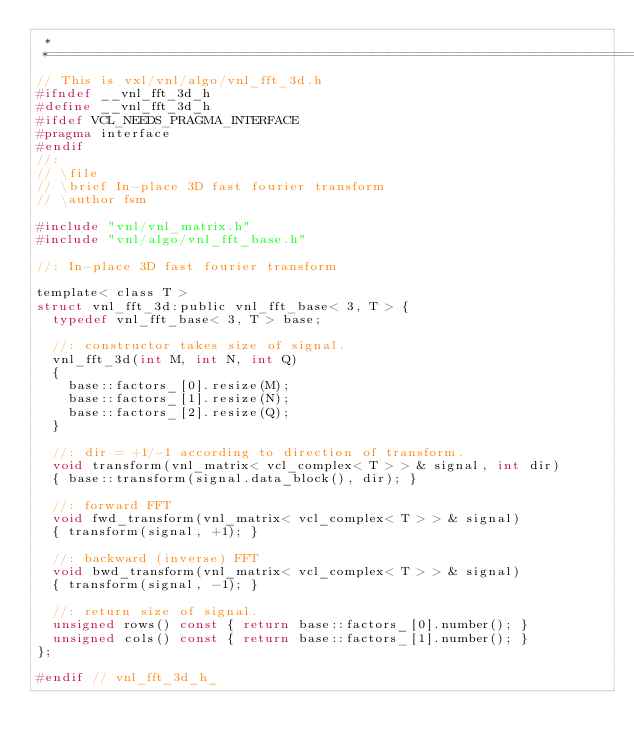Convert code to text. <code><loc_0><loc_0><loc_500><loc_500><_C_> *
 *=========================================================================*/
// This is vxl/vnl/algo/vnl_fft_3d.h
#ifndef __vnl_fft_3d_h
#define __vnl_fft_3d_h
#ifdef VCL_NEEDS_PRAGMA_INTERFACE
#pragma interface
#endif
//:
// \file
// \brief In-place 3D fast fourier transform
// \author fsm

#include "vnl/vnl_matrix.h"
#include "vnl/algo/vnl_fft_base.h"

//: In-place 3D fast fourier transform

template< class T >
struct vnl_fft_3d:public vnl_fft_base< 3, T > {
  typedef vnl_fft_base< 3, T > base;

  //: constructor takes size of signal.
  vnl_fft_3d(int M, int N, int Q)
  {
    base::factors_[0].resize(M);
    base::factors_[1].resize(N);
    base::factors_[2].resize(Q);
  }

  //: dir = +1/-1 according to direction of transform.
  void transform(vnl_matrix< vcl_complex< T > > & signal, int dir)
  { base::transform(signal.data_block(), dir); }

  //: forward FFT
  void fwd_transform(vnl_matrix< vcl_complex< T > > & signal)
  { transform(signal, +1); }

  //: backward (inverse) FFT
  void bwd_transform(vnl_matrix< vcl_complex< T > > & signal)
  { transform(signal, -1); }

  //: return size of signal.
  unsigned rows() const { return base::factors_[0].number(); }
  unsigned cols() const { return base::factors_[1].number(); }
};

#endif // vnl_fft_3d_h_
</code> 